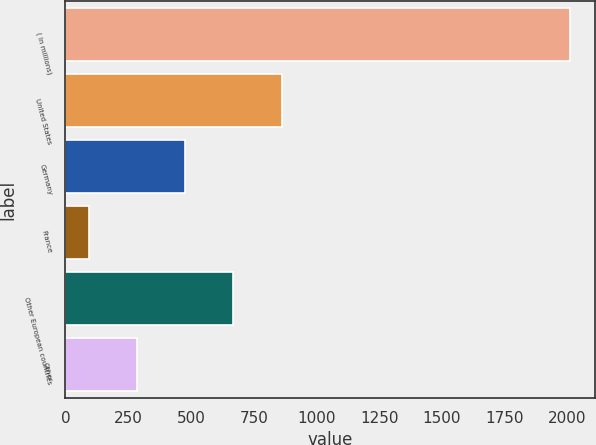<chart> <loc_0><loc_0><loc_500><loc_500><bar_chart><fcel>( in millions)<fcel>United States<fcel>Germany<fcel>France<fcel>Other European countries<fcel>Other<nl><fcel>2011<fcel>860.92<fcel>477.56<fcel>94.2<fcel>669.24<fcel>285.88<nl></chart> 